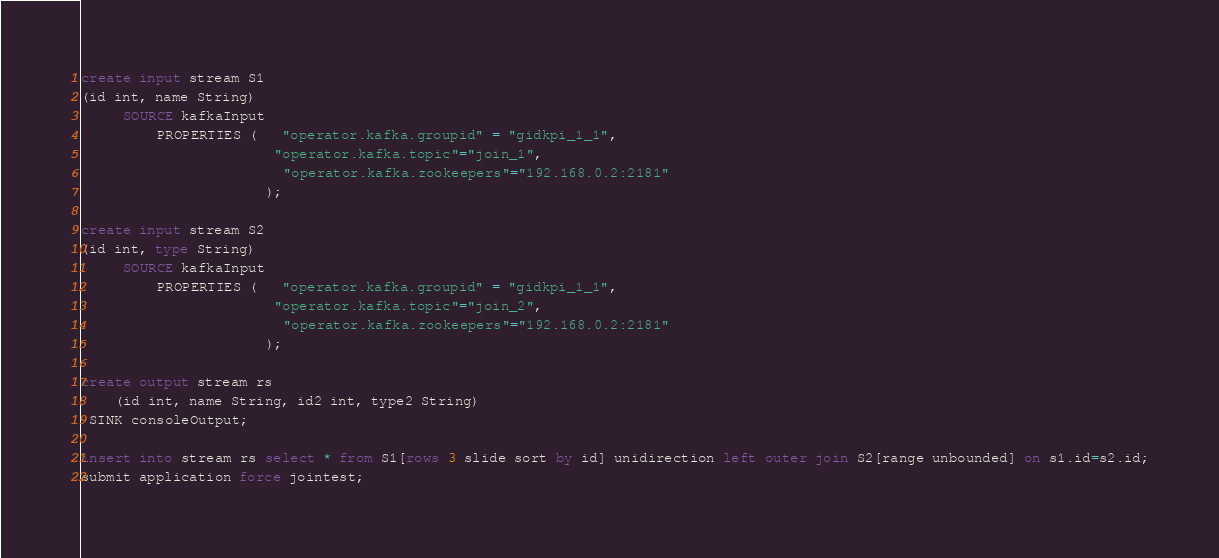<code> <loc_0><loc_0><loc_500><loc_500><_SQL_>create input stream S1 
(id int, name String)
	 SOURCE kafkaInput
		 PROPERTIES (   "operator.kafka.groupid" = "gidkpi_1_1",
                       "operator.kafka.topic"="join_1",
						"operator.kafka.zookeepers"="192.168.0.2:2181"
                      );

create input stream S2 
(id int, type String)
	 SOURCE kafkaInput
         PROPERTIES (   "operator.kafka.groupid" = "gidkpi_1_1",
                       "operator.kafka.topic"="join_2",
						"operator.kafka.zookeepers"="192.168.0.2:2181"
                      );
							
create output stream rs 
	(id int, name String, id2 int, type2 String)
 SINK consoleOutput;
					
insert into stream rs select * from S1[rows 3 slide sort by id] unidirection left outer join S2[range unbounded] on s1.id=s2.id;
submit application force jointest;
</code> 